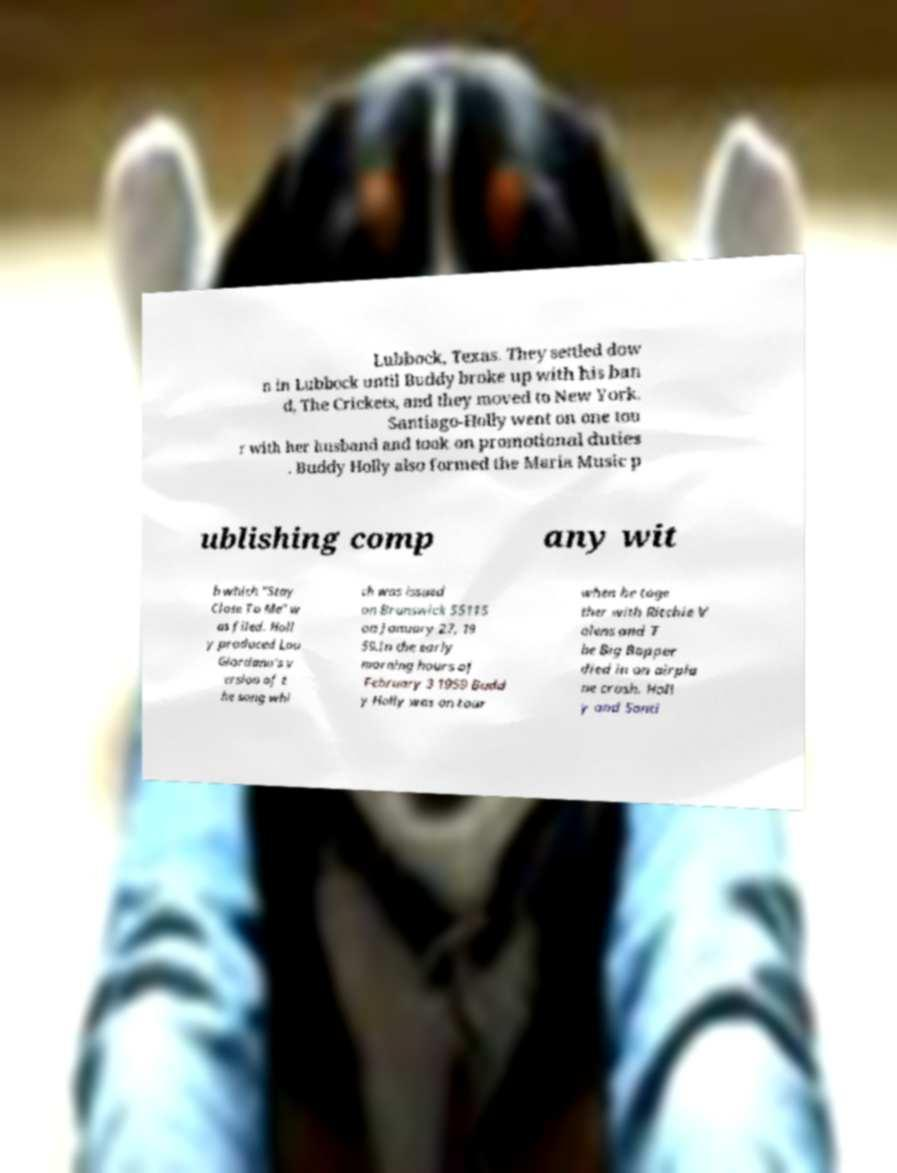I need the written content from this picture converted into text. Can you do that? Lubbock, Texas. They settled dow n in Lubbock until Buddy broke up with his ban d, The Crickets, and they moved to New York. Santiago-Holly went on one tou r with her husband and took on promotional duties . Buddy Holly also formed the Maria Music p ublishing comp any wit h which "Stay Close To Me" w as filed. Holl y produced Lou Giordano's v ersion of t he song whi ch was issued on Brunswick 55115 on January 27, 19 59.In the early morning hours of February 3 1959 Budd y Holly was on tour when he toge ther with Ritchie V alens and T he Big Bopper died in an airpla ne crash. Holl y and Santi 